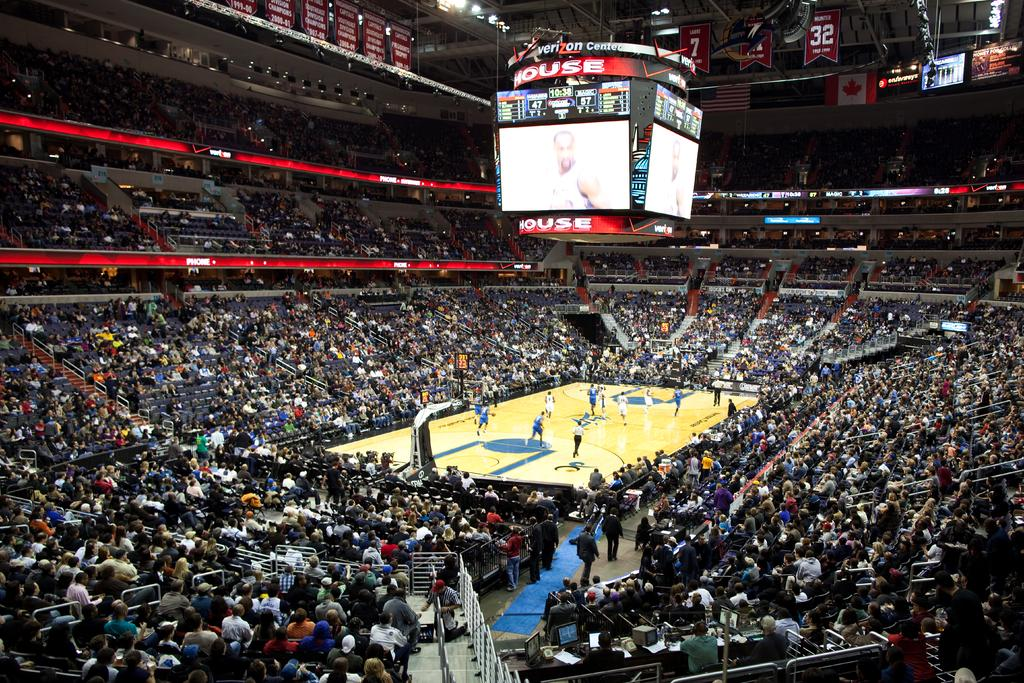<image>
Provide a brief description of the given image. a court with a large item above it that has the word house on it 